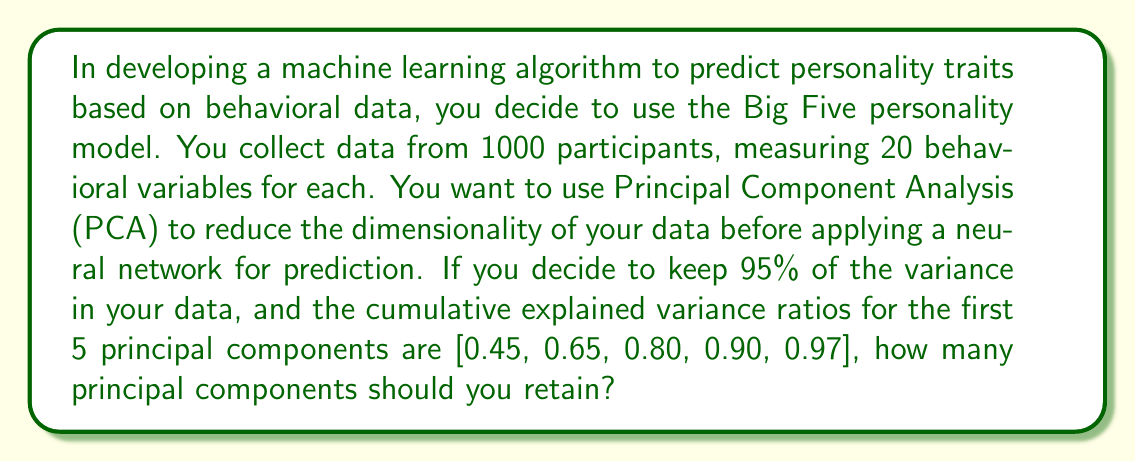What is the answer to this math problem? To solve this problem, we need to understand the concept of explained variance in PCA and how it relates to dimensionality reduction. Let's break it down step-by-step:

1. PCA is used to reduce the dimensionality of the data while retaining as much variance as possible. The explained variance ratio tells us how much of the total variance in the data is explained by each principal component.

2. The cumulative explained variance ratio is the sum of the explained variance ratios up to and including a given principal component. It represents the total proportion of variance explained by the first n components.

3. In this case, we're given the cumulative explained variance ratios for the first 5 principal components:
   $$[0.45, 0.65, 0.80, 0.90, 0.97]$$

4. We want to keep 95% of the variance in our data. This means we need to find the smallest number of components that give us a cumulative explained variance ratio of at least 0.95.

5. Let's check each component:
   - 1 component: 0.45 < 0.95
   - 2 components: 0.65 < 0.95
   - 3 components: 0.80 < 0.95
   - 4 components: 0.90 < 0.95
   - 5 components: 0.97 > 0.95

6. We see that 5 components give us a cumulative explained variance ratio of 0.97, which is greater than our target of 0.95.

Therefore, we should retain 5 principal components to keep at least 95% of the variance in our data.
Answer: 5 principal components 